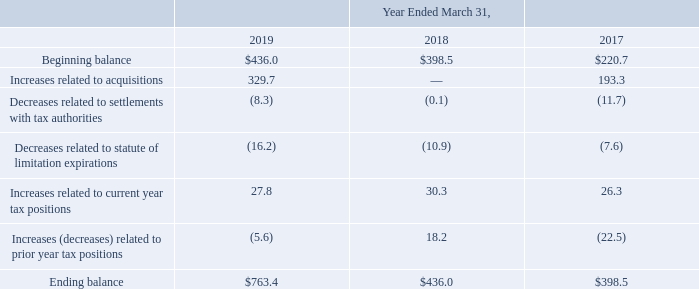The following table summarizes the activity related to the Company's gross unrecognized tax benefits from April 1, 2016 to March 31, 2019 (amounts in millions):
As of March 31, 2019 and March 31, 2018, the Company had accrued interest and penalties related to tax contingencies of $88.1 million and $80.8 million, respectively. Interest and penalties charged to operations for the years ended March 31, 2018 and 2017 related to the Company's uncertain tax positions were $5.4 million and $5.8 million, respectively. Previously accrued interest and penalties that were released during the year ended March 31, 2019 were $37.5 million.
The total amount of gross unrecognized tax benefits was $763.4 million and $436.0 million as of March 31, 2019 and March 31, 2018, respectively, of which $664.4 million and $436.0 million is estimated to impact the Company's effective tax rate, if recognized. The Company estimates that it is reasonably possible unrecognized tax benefits as of March 31, 2019 could decrease by approximately $50.0 million in the next 12 months. Positions that may be resolved include various U.S. and non-U.S. matters.
What was the total amount of gross unrecognized tax benefits in 2019?
Answer scale should be: million. 763.4. What was the company's accrued interest and penalties related to tax contingencies in 2018?
Answer scale should be: million. 80.8. What were the Increases related to acquisitions in 2017?
Answer scale should be: million. 193.3. What was the change in the Beginning balance between 2017 and 2018?
Answer scale should be: million. 398.5-220.7
Answer: 177.8. How many years did Increases related to current year tax positions exceed $30 million? 2018
Answer: 1. What was the percentage change in the Ending balance between 2018 and 2019?
Answer scale should be: percent. (763.4-436.0)/436.0
Answer: 75.09. 